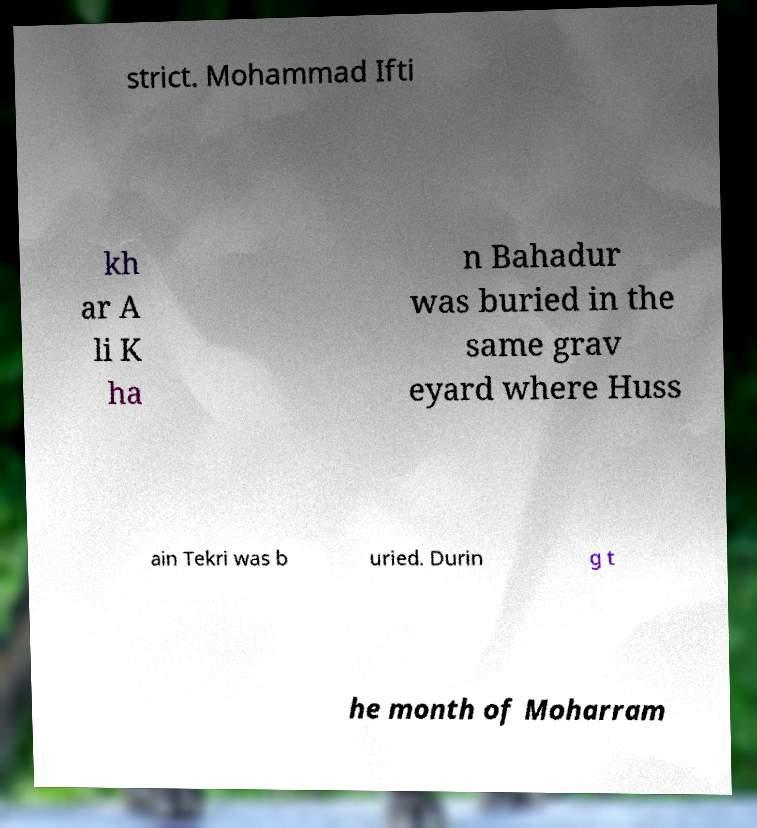Can you accurately transcribe the text from the provided image for me? strict. Mohammad Ifti kh ar A li K ha n Bahadur was buried in the same grav eyard where Huss ain Tekri was b uried. Durin g t he month of Moharram 